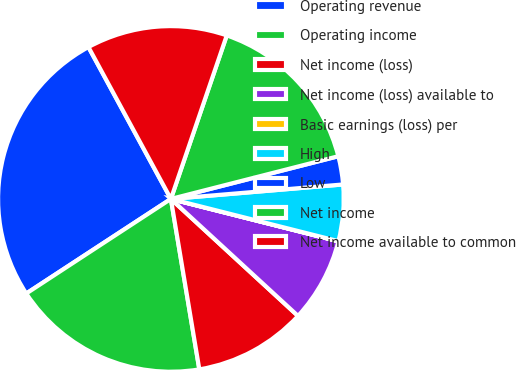Convert chart. <chart><loc_0><loc_0><loc_500><loc_500><pie_chart><fcel>Operating revenue<fcel>Operating income<fcel>Net income (loss)<fcel>Net income (loss) available to<fcel>Basic earnings (loss) per<fcel>High<fcel>Low<fcel>Net income<fcel>Net income available to common<nl><fcel>26.31%<fcel>18.42%<fcel>10.53%<fcel>7.9%<fcel>0.01%<fcel>5.27%<fcel>2.64%<fcel>15.79%<fcel>13.16%<nl></chart> 